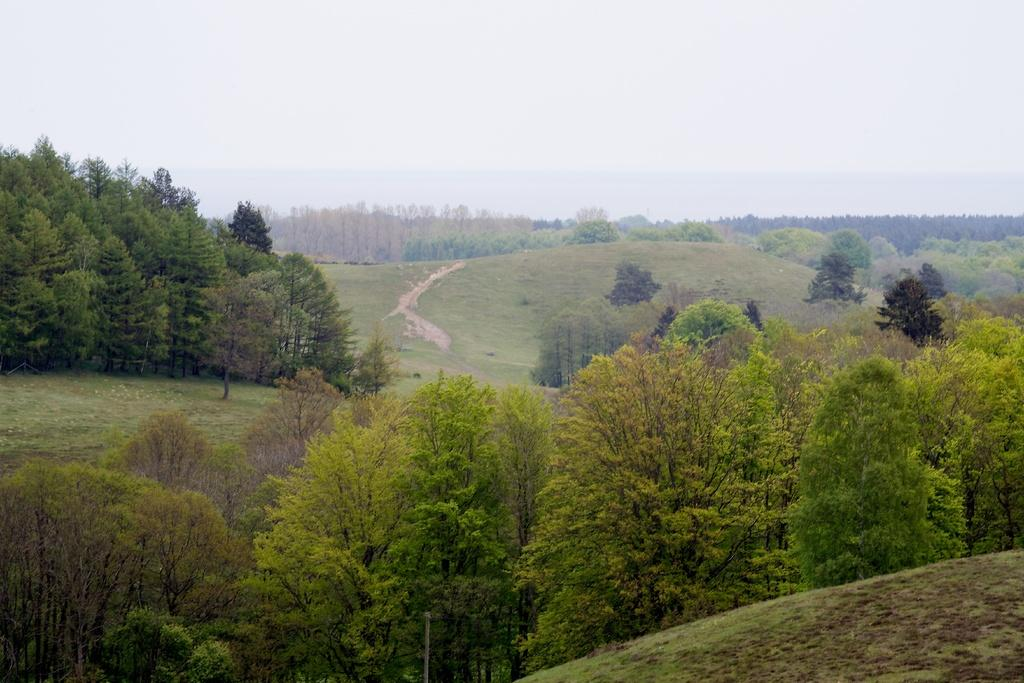What type of vegetation can be seen in the image? There are trees in the image. What is visible at the top of the image? The sky is visible at the top of the image. What part of the corn is visible in the image? There is no corn present in the image; it only features trees and the sky. Can you describe how the trees are kicking the ball in the image? There is no ball or any indication of movement or activity involving the trees in the image. 